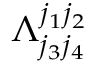Convert formula to latex. <formula><loc_0><loc_0><loc_500><loc_500>\Lambda _ { j _ { 3 } j _ { 4 } } ^ { j _ { 1 } j _ { 2 } }</formula> 